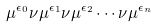Convert formula to latex. <formula><loc_0><loc_0><loc_500><loc_500>\mu ^ { \epsilon _ { 0 } } \nu \mu ^ { \epsilon _ { 1 } } \nu \mu ^ { \epsilon _ { 2 } } \cdots \nu \mu ^ { \epsilon _ { n } }</formula> 